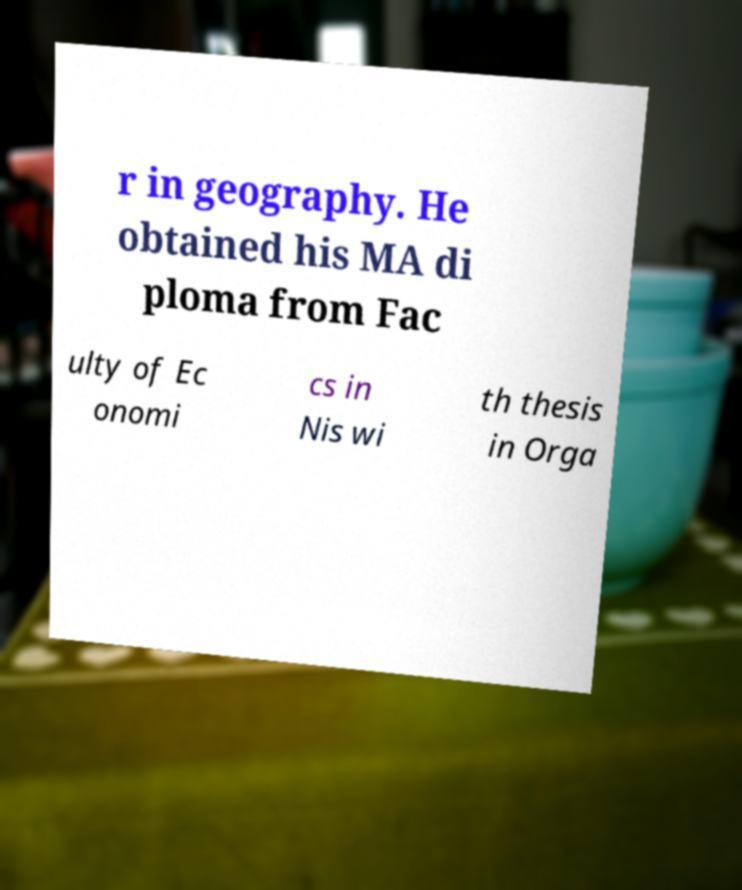For documentation purposes, I need the text within this image transcribed. Could you provide that? r in geography. He obtained his MA di ploma from Fac ulty of Ec onomi cs in Nis wi th thesis in Orga 